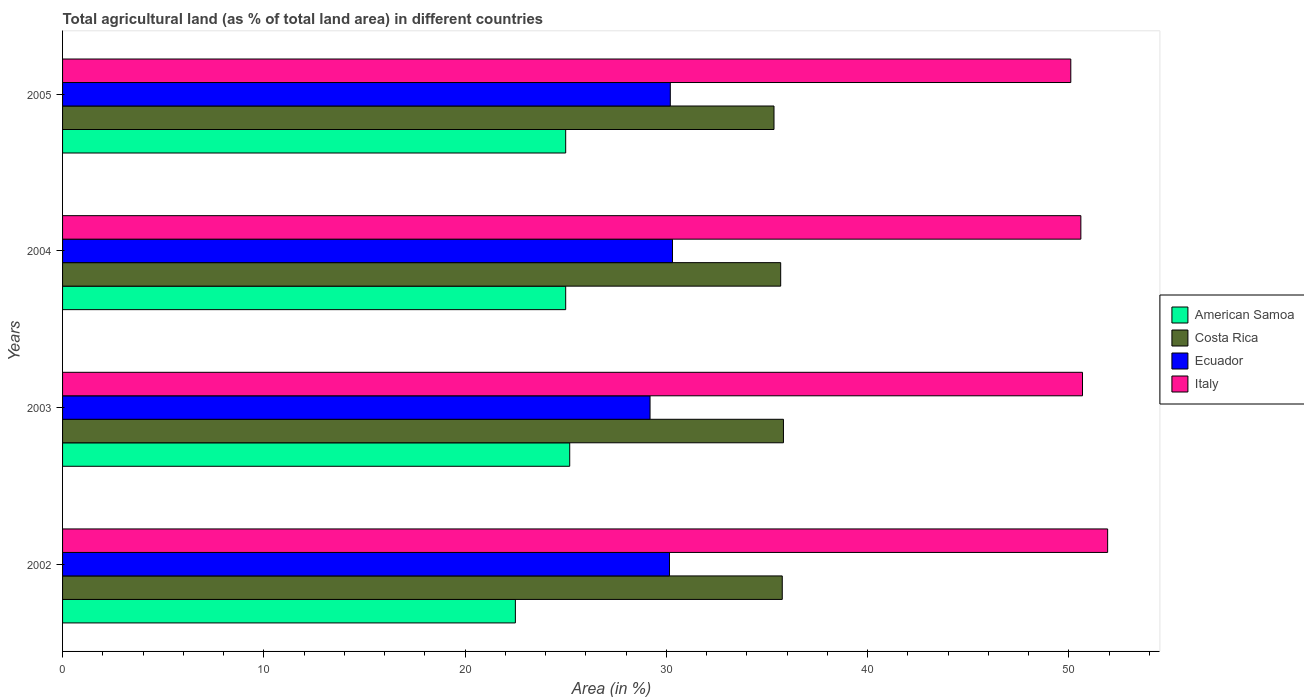Are the number of bars per tick equal to the number of legend labels?
Provide a short and direct response. Yes. Are the number of bars on each tick of the Y-axis equal?
Provide a succinct answer. Yes. How many bars are there on the 2nd tick from the bottom?
Your response must be concise. 4. In how many cases, is the number of bars for a given year not equal to the number of legend labels?
Keep it short and to the point. 0. What is the percentage of agricultural land in Costa Rica in 2002?
Your response must be concise. 35.76. Across all years, what is the maximum percentage of agricultural land in Costa Rica?
Provide a succinct answer. 35.82. Across all years, what is the minimum percentage of agricultural land in Costa Rica?
Make the answer very short. 35.35. In which year was the percentage of agricultural land in Costa Rica maximum?
Your answer should be very brief. 2003. In which year was the percentage of agricultural land in American Samoa minimum?
Your answer should be very brief. 2002. What is the total percentage of agricultural land in Ecuador in the graph?
Provide a succinct answer. 119.85. What is the difference between the percentage of agricultural land in Costa Rica in 2002 and that in 2003?
Your answer should be very brief. -0.06. What is the difference between the percentage of agricultural land in American Samoa in 2005 and the percentage of agricultural land in Ecuador in 2002?
Your response must be concise. -5.16. What is the average percentage of agricultural land in American Samoa per year?
Ensure brevity in your answer.  24.43. In the year 2005, what is the difference between the percentage of agricultural land in Costa Rica and percentage of agricultural land in Ecuador?
Ensure brevity in your answer.  5.15. In how many years, is the percentage of agricultural land in Costa Rica greater than 16 %?
Your response must be concise. 4. What is the ratio of the percentage of agricultural land in Costa Rica in 2003 to that in 2004?
Provide a short and direct response. 1. Is the percentage of agricultural land in Ecuador in 2003 less than that in 2004?
Offer a very short reply. Yes. Is the difference between the percentage of agricultural land in Costa Rica in 2004 and 2005 greater than the difference between the percentage of agricultural land in Ecuador in 2004 and 2005?
Offer a very short reply. Yes. What is the difference between the highest and the second highest percentage of agricultural land in Costa Rica?
Offer a very short reply. 0.06. What is the difference between the highest and the lowest percentage of agricultural land in American Samoa?
Offer a terse response. 2.7. What does the 4th bar from the top in 2004 represents?
Your answer should be compact. American Samoa. Is it the case that in every year, the sum of the percentage of agricultural land in Ecuador and percentage of agricultural land in Italy is greater than the percentage of agricultural land in American Samoa?
Ensure brevity in your answer.  Yes. How many bars are there?
Provide a succinct answer. 16. Are all the bars in the graph horizontal?
Offer a terse response. Yes. How many years are there in the graph?
Ensure brevity in your answer.  4. Does the graph contain any zero values?
Offer a very short reply. No. Does the graph contain grids?
Provide a succinct answer. No. How many legend labels are there?
Your answer should be compact. 4. How are the legend labels stacked?
Give a very brief answer. Vertical. What is the title of the graph?
Provide a succinct answer. Total agricultural land (as % of total land area) in different countries. Does "Costa Rica" appear as one of the legend labels in the graph?
Offer a very short reply. Yes. What is the label or title of the X-axis?
Offer a very short reply. Area (in %). What is the label or title of the Y-axis?
Provide a succinct answer. Years. What is the Area (in %) of American Samoa in 2002?
Provide a short and direct response. 22.5. What is the Area (in %) in Costa Rica in 2002?
Give a very brief answer. 35.76. What is the Area (in %) in Ecuador in 2002?
Provide a succinct answer. 30.16. What is the Area (in %) of Italy in 2002?
Give a very brief answer. 51.93. What is the Area (in %) of American Samoa in 2003?
Your response must be concise. 25.2. What is the Area (in %) in Costa Rica in 2003?
Keep it short and to the point. 35.82. What is the Area (in %) of Ecuador in 2003?
Give a very brief answer. 29.19. What is the Area (in %) of Italy in 2003?
Your response must be concise. 50.68. What is the Area (in %) in Costa Rica in 2004?
Offer a terse response. 35.68. What is the Area (in %) of Ecuador in 2004?
Give a very brief answer. 30.31. What is the Area (in %) of Italy in 2004?
Ensure brevity in your answer.  50.6. What is the Area (in %) of American Samoa in 2005?
Make the answer very short. 25. What is the Area (in %) of Costa Rica in 2005?
Provide a succinct answer. 35.35. What is the Area (in %) in Ecuador in 2005?
Offer a terse response. 30.2. What is the Area (in %) of Italy in 2005?
Your answer should be very brief. 50.1. Across all years, what is the maximum Area (in %) in American Samoa?
Ensure brevity in your answer.  25.2. Across all years, what is the maximum Area (in %) of Costa Rica?
Ensure brevity in your answer.  35.82. Across all years, what is the maximum Area (in %) in Ecuador?
Your response must be concise. 30.31. Across all years, what is the maximum Area (in %) in Italy?
Provide a succinct answer. 51.93. Across all years, what is the minimum Area (in %) of American Samoa?
Your answer should be compact. 22.5. Across all years, what is the minimum Area (in %) in Costa Rica?
Your answer should be compact. 35.35. Across all years, what is the minimum Area (in %) in Ecuador?
Provide a succinct answer. 29.19. Across all years, what is the minimum Area (in %) in Italy?
Provide a succinct answer. 50.1. What is the total Area (in %) of American Samoa in the graph?
Your response must be concise. 97.7. What is the total Area (in %) of Costa Rica in the graph?
Provide a succinct answer. 142.62. What is the total Area (in %) of Ecuador in the graph?
Provide a succinct answer. 119.85. What is the total Area (in %) of Italy in the graph?
Ensure brevity in your answer.  203.31. What is the difference between the Area (in %) in Costa Rica in 2002 and that in 2003?
Provide a short and direct response. -0.06. What is the difference between the Area (in %) of Ecuador in 2002 and that in 2003?
Keep it short and to the point. 0.97. What is the difference between the Area (in %) of Italy in 2002 and that in 2003?
Provide a short and direct response. 1.25. What is the difference between the Area (in %) in American Samoa in 2002 and that in 2004?
Provide a short and direct response. -2.5. What is the difference between the Area (in %) of Costa Rica in 2002 and that in 2004?
Your answer should be very brief. 0.08. What is the difference between the Area (in %) in Ecuador in 2002 and that in 2004?
Offer a very short reply. -0.15. What is the difference between the Area (in %) in Italy in 2002 and that in 2004?
Give a very brief answer. 1.33. What is the difference between the Area (in %) of American Samoa in 2002 and that in 2005?
Ensure brevity in your answer.  -2.5. What is the difference between the Area (in %) of Costa Rica in 2002 and that in 2005?
Give a very brief answer. 0.41. What is the difference between the Area (in %) of Ecuador in 2002 and that in 2005?
Offer a very short reply. -0.04. What is the difference between the Area (in %) in Italy in 2002 and that in 2005?
Ensure brevity in your answer.  1.83. What is the difference between the Area (in %) of American Samoa in 2003 and that in 2004?
Make the answer very short. 0.2. What is the difference between the Area (in %) of Costa Rica in 2003 and that in 2004?
Your answer should be very brief. 0.14. What is the difference between the Area (in %) of Ecuador in 2003 and that in 2004?
Give a very brief answer. -1.12. What is the difference between the Area (in %) of Italy in 2003 and that in 2004?
Your answer should be very brief. 0.08. What is the difference between the Area (in %) of Costa Rica in 2003 and that in 2005?
Provide a short and direct response. 0.47. What is the difference between the Area (in %) of Ecuador in 2003 and that in 2005?
Provide a short and direct response. -1.01. What is the difference between the Area (in %) of Italy in 2003 and that in 2005?
Offer a very short reply. 0.58. What is the difference between the Area (in %) of Costa Rica in 2004 and that in 2005?
Ensure brevity in your answer.  0.33. What is the difference between the Area (in %) in Ecuador in 2004 and that in 2005?
Keep it short and to the point. 0.11. What is the difference between the Area (in %) of Italy in 2004 and that in 2005?
Ensure brevity in your answer.  0.5. What is the difference between the Area (in %) in American Samoa in 2002 and the Area (in %) in Costa Rica in 2003?
Provide a succinct answer. -13.32. What is the difference between the Area (in %) of American Samoa in 2002 and the Area (in %) of Ecuador in 2003?
Make the answer very short. -6.69. What is the difference between the Area (in %) of American Samoa in 2002 and the Area (in %) of Italy in 2003?
Make the answer very short. -28.18. What is the difference between the Area (in %) of Costa Rica in 2002 and the Area (in %) of Ecuador in 2003?
Provide a short and direct response. 6.57. What is the difference between the Area (in %) of Costa Rica in 2002 and the Area (in %) of Italy in 2003?
Offer a terse response. -14.92. What is the difference between the Area (in %) of Ecuador in 2002 and the Area (in %) of Italy in 2003?
Keep it short and to the point. -20.52. What is the difference between the Area (in %) of American Samoa in 2002 and the Area (in %) of Costa Rica in 2004?
Offer a very short reply. -13.18. What is the difference between the Area (in %) in American Samoa in 2002 and the Area (in %) in Ecuador in 2004?
Your answer should be compact. -7.81. What is the difference between the Area (in %) of American Samoa in 2002 and the Area (in %) of Italy in 2004?
Ensure brevity in your answer.  -28.1. What is the difference between the Area (in %) of Costa Rica in 2002 and the Area (in %) of Ecuador in 2004?
Provide a succinct answer. 5.46. What is the difference between the Area (in %) in Costa Rica in 2002 and the Area (in %) in Italy in 2004?
Give a very brief answer. -14.84. What is the difference between the Area (in %) in Ecuador in 2002 and the Area (in %) in Italy in 2004?
Your answer should be compact. -20.44. What is the difference between the Area (in %) in American Samoa in 2002 and the Area (in %) in Costa Rica in 2005?
Your answer should be compact. -12.85. What is the difference between the Area (in %) in American Samoa in 2002 and the Area (in %) in Ecuador in 2005?
Ensure brevity in your answer.  -7.7. What is the difference between the Area (in %) in American Samoa in 2002 and the Area (in %) in Italy in 2005?
Provide a short and direct response. -27.6. What is the difference between the Area (in %) in Costa Rica in 2002 and the Area (in %) in Ecuador in 2005?
Provide a succinct answer. 5.56. What is the difference between the Area (in %) in Costa Rica in 2002 and the Area (in %) in Italy in 2005?
Your answer should be very brief. -14.34. What is the difference between the Area (in %) of Ecuador in 2002 and the Area (in %) of Italy in 2005?
Offer a terse response. -19.94. What is the difference between the Area (in %) of American Samoa in 2003 and the Area (in %) of Costa Rica in 2004?
Offer a terse response. -10.48. What is the difference between the Area (in %) of American Samoa in 2003 and the Area (in %) of Ecuador in 2004?
Offer a very short reply. -5.11. What is the difference between the Area (in %) in American Samoa in 2003 and the Area (in %) in Italy in 2004?
Offer a terse response. -25.4. What is the difference between the Area (in %) in Costa Rica in 2003 and the Area (in %) in Ecuador in 2004?
Provide a succinct answer. 5.51. What is the difference between the Area (in %) in Costa Rica in 2003 and the Area (in %) in Italy in 2004?
Your answer should be compact. -14.78. What is the difference between the Area (in %) of Ecuador in 2003 and the Area (in %) of Italy in 2004?
Give a very brief answer. -21.41. What is the difference between the Area (in %) in American Samoa in 2003 and the Area (in %) in Costa Rica in 2005?
Provide a succinct answer. -10.15. What is the difference between the Area (in %) of American Samoa in 2003 and the Area (in %) of Ecuador in 2005?
Your answer should be very brief. -5. What is the difference between the Area (in %) in American Samoa in 2003 and the Area (in %) in Italy in 2005?
Ensure brevity in your answer.  -24.9. What is the difference between the Area (in %) in Costa Rica in 2003 and the Area (in %) in Ecuador in 2005?
Keep it short and to the point. 5.62. What is the difference between the Area (in %) in Costa Rica in 2003 and the Area (in %) in Italy in 2005?
Offer a terse response. -14.28. What is the difference between the Area (in %) of Ecuador in 2003 and the Area (in %) of Italy in 2005?
Provide a succinct answer. -20.91. What is the difference between the Area (in %) of American Samoa in 2004 and the Area (in %) of Costa Rica in 2005?
Offer a very short reply. -10.35. What is the difference between the Area (in %) of American Samoa in 2004 and the Area (in %) of Ecuador in 2005?
Your answer should be very brief. -5.2. What is the difference between the Area (in %) in American Samoa in 2004 and the Area (in %) in Italy in 2005?
Your answer should be compact. -25.1. What is the difference between the Area (in %) in Costa Rica in 2004 and the Area (in %) in Ecuador in 2005?
Your response must be concise. 5.49. What is the difference between the Area (in %) in Costa Rica in 2004 and the Area (in %) in Italy in 2005?
Your answer should be compact. -14.42. What is the difference between the Area (in %) in Ecuador in 2004 and the Area (in %) in Italy in 2005?
Make the answer very short. -19.79. What is the average Area (in %) in American Samoa per year?
Your answer should be very brief. 24.43. What is the average Area (in %) of Costa Rica per year?
Make the answer very short. 35.65. What is the average Area (in %) in Ecuador per year?
Ensure brevity in your answer.  29.96. What is the average Area (in %) in Italy per year?
Ensure brevity in your answer.  50.83. In the year 2002, what is the difference between the Area (in %) of American Samoa and Area (in %) of Costa Rica?
Offer a terse response. -13.26. In the year 2002, what is the difference between the Area (in %) of American Samoa and Area (in %) of Ecuador?
Your response must be concise. -7.66. In the year 2002, what is the difference between the Area (in %) of American Samoa and Area (in %) of Italy?
Provide a succinct answer. -29.43. In the year 2002, what is the difference between the Area (in %) of Costa Rica and Area (in %) of Ecuador?
Your answer should be very brief. 5.6. In the year 2002, what is the difference between the Area (in %) of Costa Rica and Area (in %) of Italy?
Give a very brief answer. -16.17. In the year 2002, what is the difference between the Area (in %) of Ecuador and Area (in %) of Italy?
Provide a short and direct response. -21.77. In the year 2003, what is the difference between the Area (in %) of American Samoa and Area (in %) of Costa Rica?
Make the answer very short. -10.62. In the year 2003, what is the difference between the Area (in %) in American Samoa and Area (in %) in Ecuador?
Ensure brevity in your answer.  -3.99. In the year 2003, what is the difference between the Area (in %) of American Samoa and Area (in %) of Italy?
Your answer should be very brief. -25.48. In the year 2003, what is the difference between the Area (in %) of Costa Rica and Area (in %) of Ecuador?
Make the answer very short. 6.63. In the year 2003, what is the difference between the Area (in %) in Costa Rica and Area (in %) in Italy?
Keep it short and to the point. -14.86. In the year 2003, what is the difference between the Area (in %) in Ecuador and Area (in %) in Italy?
Provide a succinct answer. -21.49. In the year 2004, what is the difference between the Area (in %) in American Samoa and Area (in %) in Costa Rica?
Make the answer very short. -10.68. In the year 2004, what is the difference between the Area (in %) of American Samoa and Area (in %) of Ecuador?
Keep it short and to the point. -5.31. In the year 2004, what is the difference between the Area (in %) of American Samoa and Area (in %) of Italy?
Provide a succinct answer. -25.6. In the year 2004, what is the difference between the Area (in %) of Costa Rica and Area (in %) of Ecuador?
Provide a succinct answer. 5.38. In the year 2004, what is the difference between the Area (in %) of Costa Rica and Area (in %) of Italy?
Provide a short and direct response. -14.91. In the year 2004, what is the difference between the Area (in %) in Ecuador and Area (in %) in Italy?
Offer a terse response. -20.29. In the year 2005, what is the difference between the Area (in %) of American Samoa and Area (in %) of Costa Rica?
Your answer should be very brief. -10.35. In the year 2005, what is the difference between the Area (in %) of American Samoa and Area (in %) of Ecuador?
Your answer should be very brief. -5.2. In the year 2005, what is the difference between the Area (in %) in American Samoa and Area (in %) in Italy?
Offer a very short reply. -25.1. In the year 2005, what is the difference between the Area (in %) in Costa Rica and Area (in %) in Ecuador?
Give a very brief answer. 5.15. In the year 2005, what is the difference between the Area (in %) in Costa Rica and Area (in %) in Italy?
Keep it short and to the point. -14.75. In the year 2005, what is the difference between the Area (in %) in Ecuador and Area (in %) in Italy?
Your answer should be very brief. -19.9. What is the ratio of the Area (in %) in American Samoa in 2002 to that in 2003?
Your answer should be very brief. 0.89. What is the ratio of the Area (in %) of Ecuador in 2002 to that in 2003?
Offer a very short reply. 1.03. What is the ratio of the Area (in %) in Italy in 2002 to that in 2003?
Give a very brief answer. 1.02. What is the ratio of the Area (in %) in Ecuador in 2002 to that in 2004?
Give a very brief answer. 1. What is the ratio of the Area (in %) in Italy in 2002 to that in 2004?
Your answer should be compact. 1.03. What is the ratio of the Area (in %) of Costa Rica in 2002 to that in 2005?
Offer a terse response. 1.01. What is the ratio of the Area (in %) of Ecuador in 2002 to that in 2005?
Your answer should be very brief. 1. What is the ratio of the Area (in %) of Italy in 2002 to that in 2005?
Provide a short and direct response. 1.04. What is the ratio of the Area (in %) in Costa Rica in 2003 to that in 2004?
Give a very brief answer. 1. What is the ratio of the Area (in %) in Ecuador in 2003 to that in 2004?
Ensure brevity in your answer.  0.96. What is the ratio of the Area (in %) of Costa Rica in 2003 to that in 2005?
Offer a terse response. 1.01. What is the ratio of the Area (in %) of Ecuador in 2003 to that in 2005?
Your response must be concise. 0.97. What is the ratio of the Area (in %) of Italy in 2003 to that in 2005?
Your answer should be compact. 1.01. What is the ratio of the Area (in %) in American Samoa in 2004 to that in 2005?
Provide a succinct answer. 1. What is the ratio of the Area (in %) in Costa Rica in 2004 to that in 2005?
Offer a very short reply. 1.01. What is the ratio of the Area (in %) in Ecuador in 2004 to that in 2005?
Provide a succinct answer. 1. What is the difference between the highest and the second highest Area (in %) in Costa Rica?
Your answer should be compact. 0.06. What is the difference between the highest and the second highest Area (in %) of Ecuador?
Provide a succinct answer. 0.11. What is the difference between the highest and the second highest Area (in %) of Italy?
Your answer should be very brief. 1.25. What is the difference between the highest and the lowest Area (in %) in American Samoa?
Your answer should be very brief. 2.7. What is the difference between the highest and the lowest Area (in %) in Costa Rica?
Ensure brevity in your answer.  0.47. What is the difference between the highest and the lowest Area (in %) of Ecuador?
Offer a very short reply. 1.12. What is the difference between the highest and the lowest Area (in %) in Italy?
Provide a succinct answer. 1.83. 